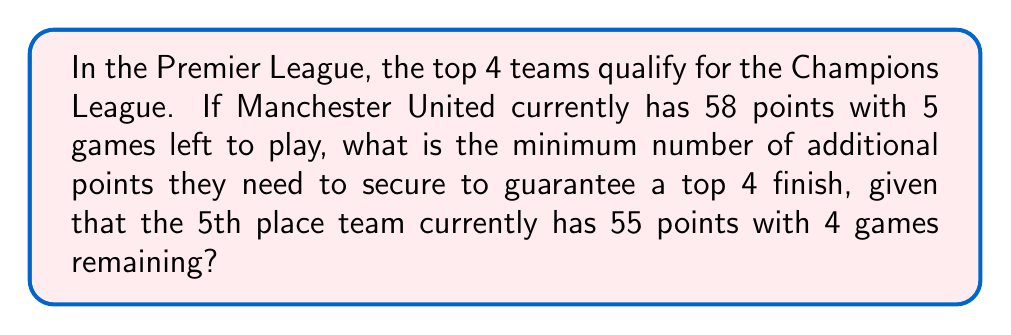Can you answer this question? Let's approach this step-by-step:

1) First, we need to calculate the maximum points the 5th place team can achieve:
   Current points + (Games remaining × Points per win)
   $$ 55 + (4 \times 3) = 55 + 12 = 67 $$

2) Manchester United needs to surpass this total to guarantee a top 4 finish.

3) Manchester United's current points: 58

4) To surpass 67 points, Manchester United needs at least 68 points.

5) Additional points needed:
   $$ 68 - 58 = 10 $$

6) However, we need to consider that points are awarded in whole numbers (3 for a win, 1 for a draw). The minimum number of additional points that exceeds 10 and is achievable in 5 games is 11 points.

7) This could be achieved with 3 wins and 2 draws: $(3 \times 3) + (2 \times 1) = 9 + 2 = 11$

Therefore, Manchester United needs a minimum of 11 additional points to guarantee a top 4 finish.
Answer: 11 points 